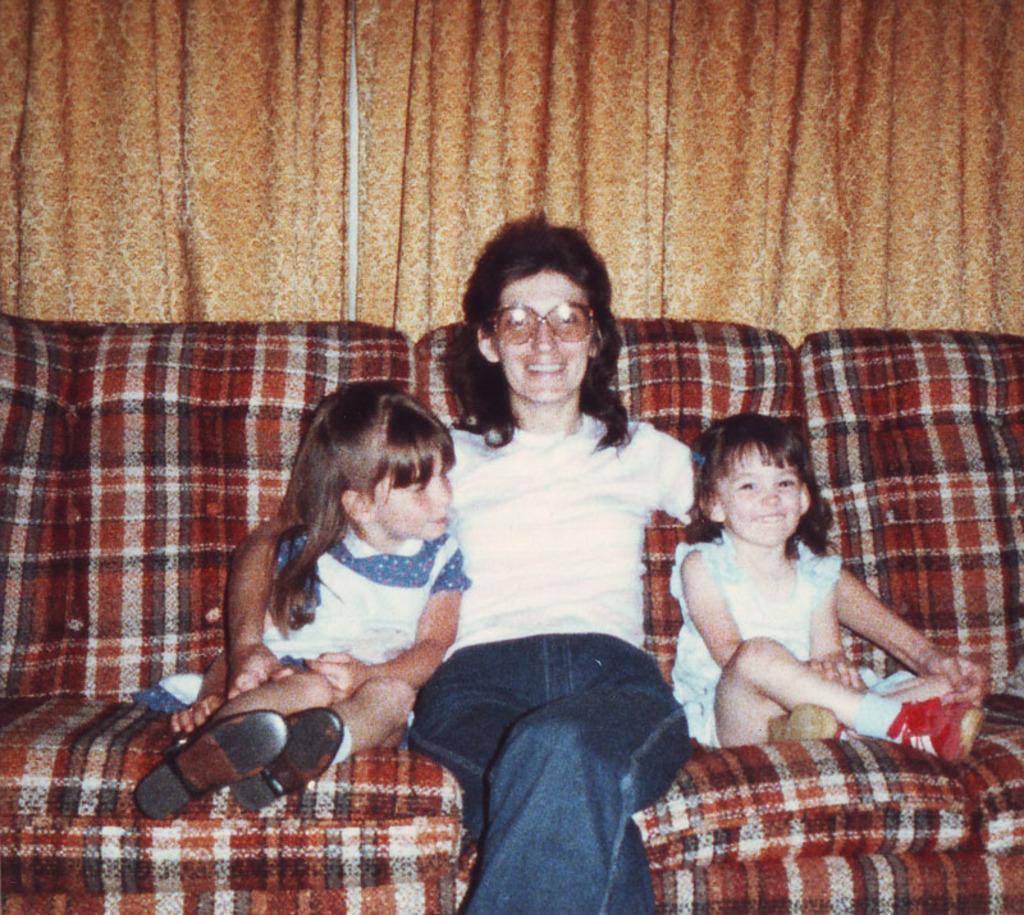Describe this image in one or two sentences. In this image we can see a woman and two children sitting on the couch. At the back side there is a curtain. The woman is smiling. 